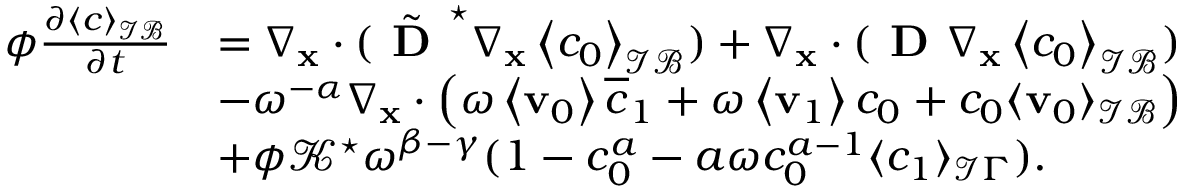Convert formula to latex. <formula><loc_0><loc_0><loc_500><loc_500>\begin{array} { r l } { \phi \frac { \partial \left \langle c \right \rangle _ { \mathcal { I B } } } { \partial t } } & { = \nabla _ { x } \cdot ( \tilde { D } ^ { ^ { * } } \nabla _ { \mathbf x } \left \langle c _ { 0 } \right \rangle _ { \mathcal { I B } } ) + \nabla _ { \mathbf x } \cdot ( D \nabla _ { \mathbf x } \left \langle c _ { 0 } \right \rangle _ { \mathcal { I B } } ) } \\ & { - \omega ^ { - \alpha } \nabla _ { \mathbf x } \cdot \left ( \omega \left \langle \mathbf v _ { 0 } \right \rangle \overline { c } _ { 1 } + \omega \left \langle \mathbf v _ { 1 } \right \rangle c _ { 0 } + c _ { 0 } \langle \mathbf v _ { 0 } \rangle _ { \mathcal { I B } } \right ) } \\ & { + \phi \mathcal { K } ^ { ^ { * } } \omega ^ { \beta - \gamma } ( 1 - c _ { 0 } ^ { a } - a \omega c _ { 0 } ^ { a - 1 } \langle c _ { 1 } \rangle _ { \mathcal { I } \Gamma } ) . } \end{array}</formula> 